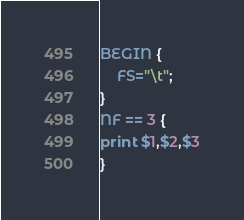Convert code to text. <code><loc_0><loc_0><loc_500><loc_500><_Awk_>BEGIN {
	FS="\t";
}
NF == 3 {
print $1,$2,$3
}
</code> 